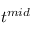Convert formula to latex. <formula><loc_0><loc_0><loc_500><loc_500>t ^ { m i d }</formula> 